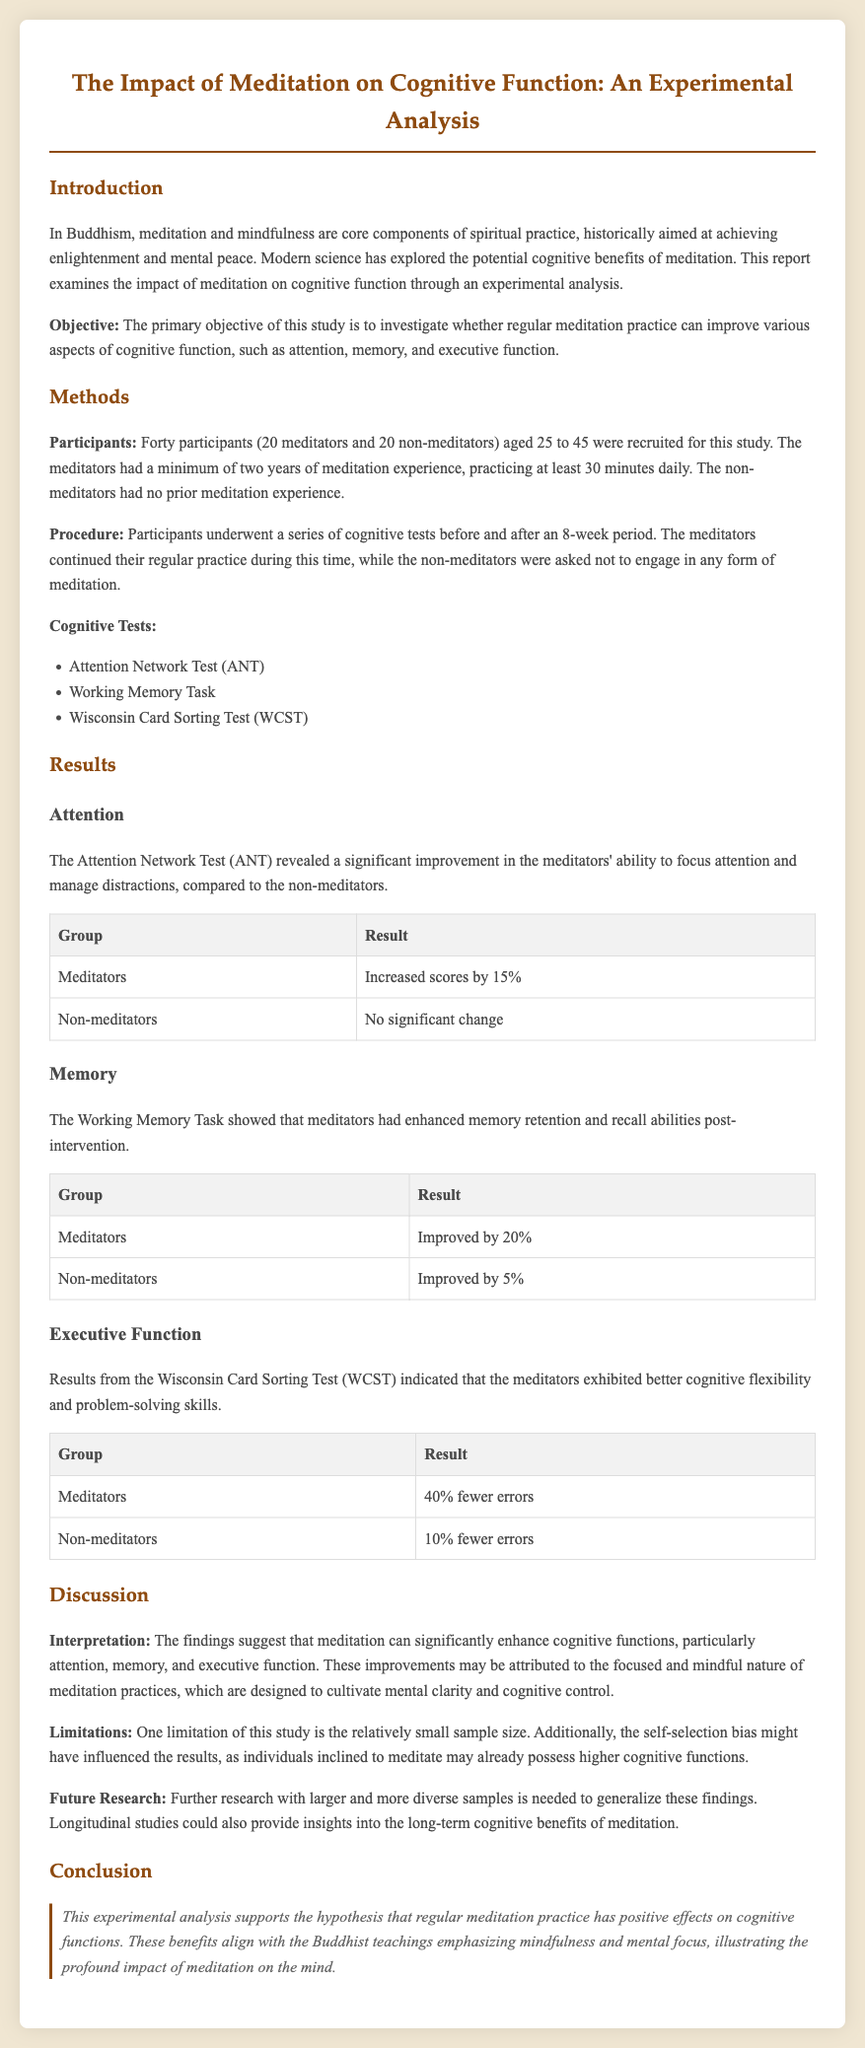What was the sample size of the study? The sample size of the study consisted of 40 participants.
Answer: 40 participants What age range did the participants fall into? The participants were aged between 25 to 45 years.
Answer: 25 to 45 years What cognitive test showed a 15% score increase for meditators? The Attention Network Test (ANT) revealed a significant improvement in the meditators' ability to focus attention.
Answer: Attention Network Test What was the improvement percentage for non-meditators in the Working Memory Task? Non-meditators improved by 5% in the Working Memory Task.
Answer: 5% How many fewer errors did meditators have in the Wisconsin Card Sorting Test? Meditators exhibited 40% fewer errors in the Wisconsin Card Sorting Test.
Answer: 40% What was identified as a limitation of the study? One limitation of this study is the relatively small sample size.
Answer: Small sample size What is a future research suggestion mentioned in the document? Further research with larger and more diverse samples is needed.
Answer: Larger and more diverse samples What is the primary objective of the study? The primary objective is to investigate whether regular meditation practice can improve various aspects of cognitive function.
Answer: Improve cognitive function Which cognitive function showed the most significant improvement according to the discussion? The findings suggest that meditation can significantly enhance cognitive functions, particularly attention.
Answer: Attention 